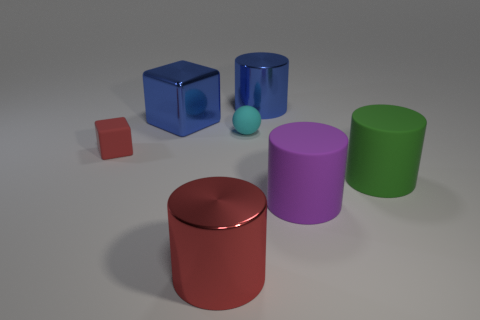There is a object that is the same color as the small matte block; what size is it?
Provide a succinct answer. Large. What color is the metallic cylinder that is left of the sphere?
Your answer should be compact. Red. Do the matte block and the purple cylinder have the same size?
Your response must be concise. No. There is a red thing behind the shiny cylinder in front of the tiny cube; what is it made of?
Make the answer very short. Rubber. What number of shiny objects are the same color as the rubber cube?
Make the answer very short. 1. Are there fewer large things behind the large cube than large green matte cylinders?
Offer a terse response. No. The cylinder to the left of the metallic cylinder on the right side of the large red metal cylinder is what color?
Offer a very short reply. Red. What size is the rubber thing to the left of the blue metal thing that is left of the cylinder that is behind the green object?
Make the answer very short. Small. Is the number of big cylinders behind the metal cube less than the number of metallic objects behind the rubber sphere?
Ensure brevity in your answer.  Yes. How many other objects are made of the same material as the big red thing?
Your answer should be very brief. 2. 